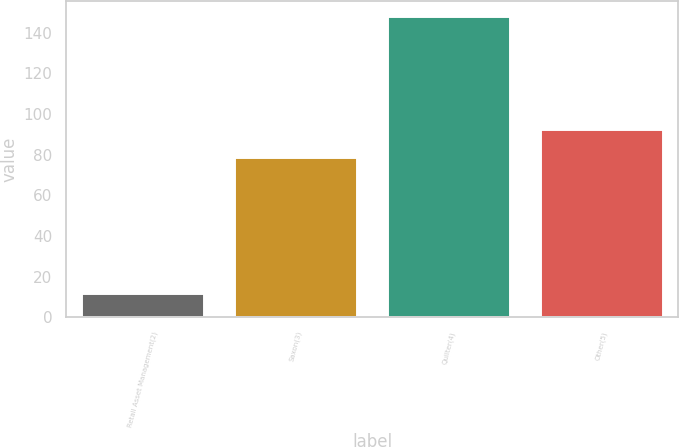<chart> <loc_0><loc_0><loc_500><loc_500><bar_chart><fcel>Retail Asset Management(2)<fcel>Saxon(3)<fcel>Quilter(4)<fcel>Other(5)<nl><fcel>12<fcel>79<fcel>148<fcel>92.6<nl></chart> 